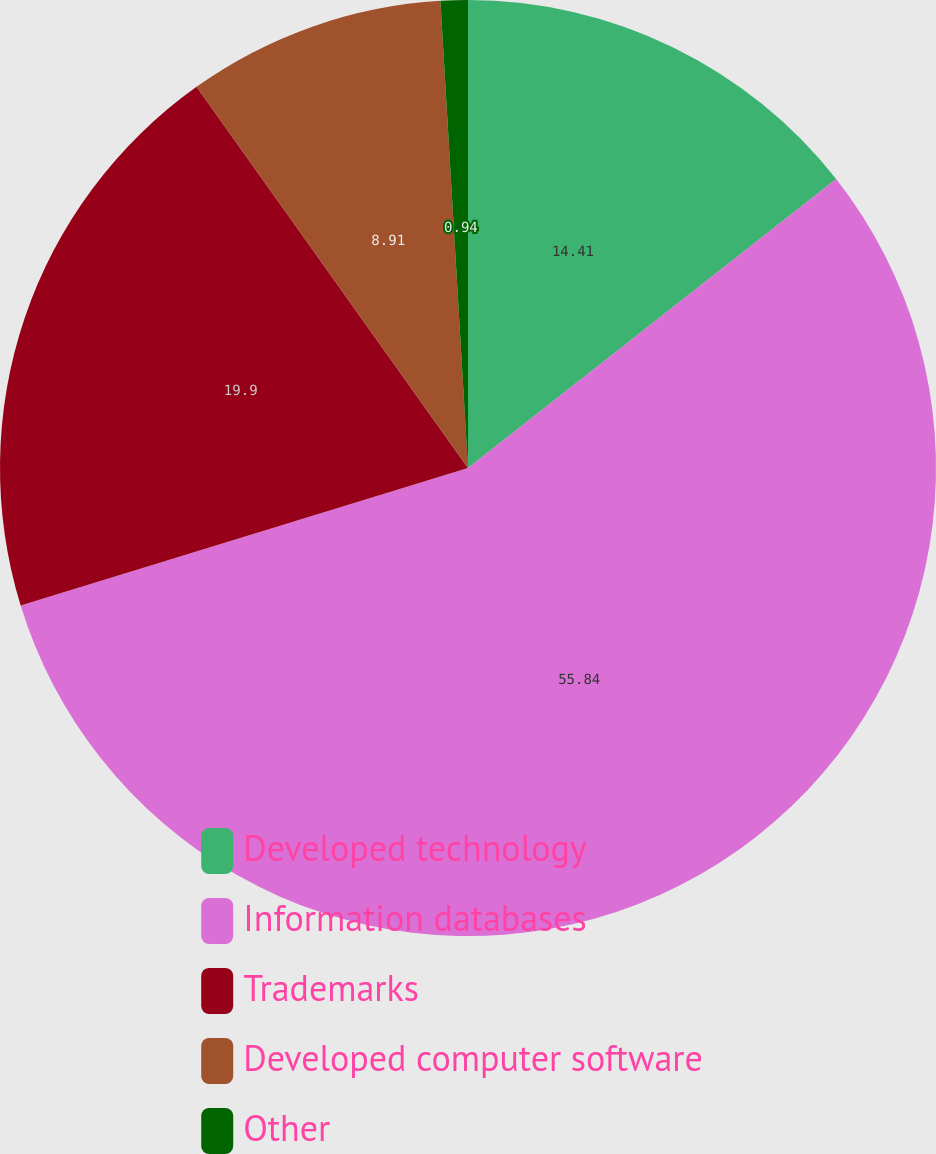Convert chart to OTSL. <chart><loc_0><loc_0><loc_500><loc_500><pie_chart><fcel>Developed technology<fcel>Information databases<fcel>Trademarks<fcel>Developed computer software<fcel>Other<nl><fcel>14.41%<fcel>55.85%<fcel>19.9%<fcel>8.91%<fcel>0.94%<nl></chart> 